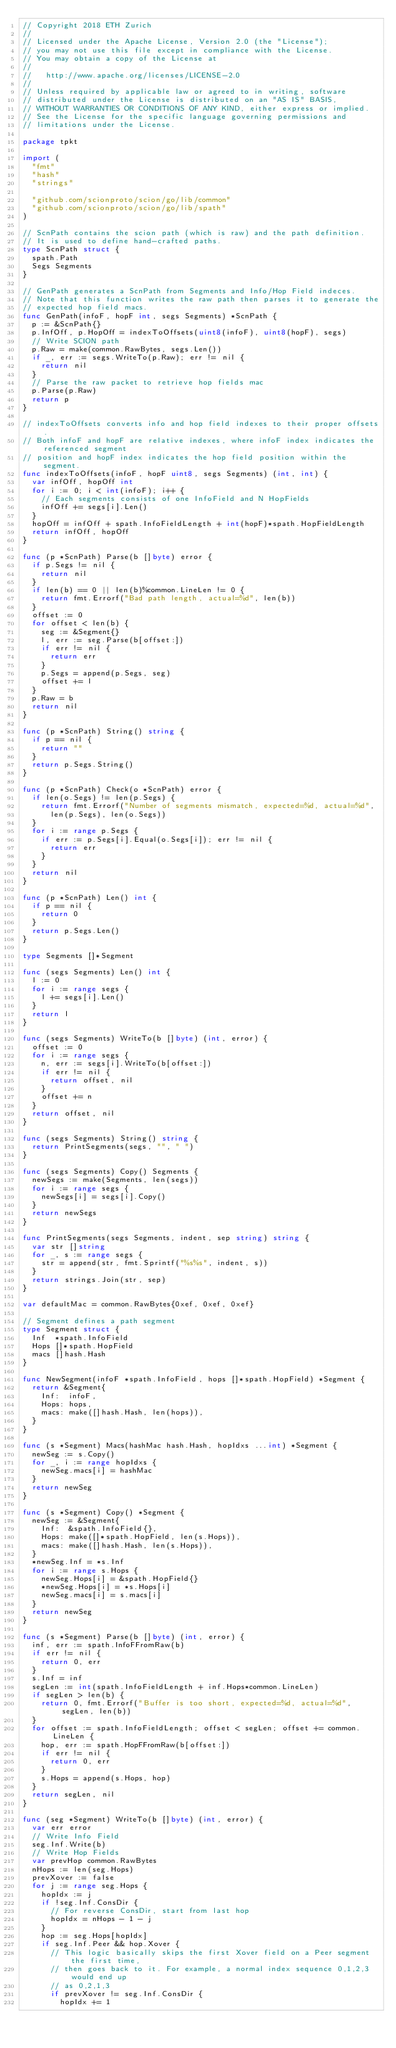<code> <loc_0><loc_0><loc_500><loc_500><_Go_>// Copyright 2018 ETH Zurich
//
// Licensed under the Apache License, Version 2.0 (the "License");
// you may not use this file except in compliance with the License.
// You may obtain a copy of the License at
//
//   http://www.apache.org/licenses/LICENSE-2.0
//
// Unless required by applicable law or agreed to in writing, software
// distributed under the License is distributed on an "AS IS" BASIS,
// WITHOUT WARRANTIES OR CONDITIONS OF ANY KIND, either express or implied.
// See the License for the specific language governing permissions and
// limitations under the License.

package tpkt

import (
	"fmt"
	"hash"
	"strings"

	"github.com/scionproto/scion/go/lib/common"
	"github.com/scionproto/scion/go/lib/spath"
)

// ScnPath contains the scion path (which is raw) and the path definition.
// It is used to define hand-crafted paths.
type ScnPath struct {
	spath.Path
	Segs Segments
}

// GenPath generates a ScnPath from Segments and Info/Hop Field indeces.
// Note that this function writes the raw path then parses it to generate the
// expected hop field macs.
func GenPath(infoF, hopF int, segs Segments) *ScnPath {
	p := &ScnPath{}
	p.InfOff, p.HopOff = indexToOffsets(uint8(infoF), uint8(hopF), segs)
	// Write SCION path
	p.Raw = make(common.RawBytes, segs.Len())
	if _, err := segs.WriteTo(p.Raw); err != nil {
		return nil
	}
	// Parse the raw packet to retrieve hop fields mac
	p.Parse(p.Raw)
	return p
}

// indexToOffsets converts info and hop field indexes to their proper offsets.
// Both infoF and hopF are relative indexes, where infoF index indicates the referenced segment
// position and hopF index indicates the hop field position within the segment.
func indexToOffsets(infoF, hopF uint8, segs Segments) (int, int) {
	var infOff, hopOff int
	for i := 0; i < int(infoF); i++ {
		// Each segments consists of one InfoField and N HopFields
		infOff += segs[i].Len()
	}
	hopOff = infOff + spath.InfoFieldLength + int(hopF)*spath.HopFieldLength
	return infOff, hopOff
}

func (p *ScnPath) Parse(b []byte) error {
	if p.Segs != nil {
		return nil
	}
	if len(b) == 0 || len(b)%common.LineLen != 0 {
		return fmt.Errorf("Bad path length, actual=%d", len(b))
	}
	offset := 0
	for offset < len(b) {
		seg := &Segment{}
		l, err := seg.Parse(b[offset:])
		if err != nil {
			return err
		}
		p.Segs = append(p.Segs, seg)
		offset += l
	}
	p.Raw = b
	return nil
}

func (p *ScnPath) String() string {
	if p == nil {
		return ""
	}
	return p.Segs.String()
}

func (p *ScnPath) Check(o *ScnPath) error {
	if len(o.Segs) != len(p.Segs) {
		return fmt.Errorf("Number of segments mismatch, expected=%d, actual=%d",
			len(p.Segs), len(o.Segs))
	}
	for i := range p.Segs {
		if err := p.Segs[i].Equal(o.Segs[i]); err != nil {
			return err
		}
	}
	return nil
}

func (p *ScnPath) Len() int {
	if p == nil {
		return 0
	}
	return p.Segs.Len()
}

type Segments []*Segment

func (segs Segments) Len() int {
	l := 0
	for i := range segs {
		l += segs[i].Len()
	}
	return l
}

func (segs Segments) WriteTo(b []byte) (int, error) {
	offset := 0
	for i := range segs {
		n, err := segs[i].WriteTo(b[offset:])
		if err != nil {
			return offset, nil
		}
		offset += n
	}
	return offset, nil
}

func (segs Segments) String() string {
	return PrintSegments(segs, "", " ")
}

func (segs Segments) Copy() Segments {
	newSegs := make(Segments, len(segs))
	for i := range segs {
		newSegs[i] = segs[i].Copy()
	}
	return newSegs
}

func PrintSegments(segs Segments, indent, sep string) string {
	var str []string
	for _, s := range segs {
		str = append(str, fmt.Sprintf("%s%s", indent, s))
	}
	return strings.Join(str, sep)
}

var defaultMac = common.RawBytes{0xef, 0xef, 0xef}

// Segment defines a path segment
type Segment struct {
	Inf  *spath.InfoField
	Hops []*spath.HopField
	macs []hash.Hash
}

func NewSegment(infoF *spath.InfoField, hops []*spath.HopField) *Segment {
	return &Segment{
		Inf:  infoF,
		Hops: hops,
		macs: make([]hash.Hash, len(hops)),
	}
}

func (s *Segment) Macs(hashMac hash.Hash, hopIdxs ...int) *Segment {
	newSeg := s.Copy()
	for _, i := range hopIdxs {
		newSeg.macs[i] = hashMac
	}
	return newSeg
}

func (s *Segment) Copy() *Segment {
	newSeg := &Segment{
		Inf:  &spath.InfoField{},
		Hops: make([]*spath.HopField, len(s.Hops)),
		macs: make([]hash.Hash, len(s.Hops)),
	}
	*newSeg.Inf = *s.Inf
	for i := range s.Hops {
		newSeg.Hops[i] = &spath.HopField{}
		*newSeg.Hops[i] = *s.Hops[i]
		newSeg.macs[i] = s.macs[i]
	}
	return newSeg
}

func (s *Segment) Parse(b []byte) (int, error) {
	inf, err := spath.InfoFFromRaw(b)
	if err != nil {
		return 0, err
	}
	s.Inf = inf
	segLen := int(spath.InfoFieldLength + inf.Hops*common.LineLen)
	if segLen > len(b) {
		return 0, fmt.Errorf("Buffer is too short, expected=%d, actual=%d", segLen, len(b))
	}
	for offset := spath.InfoFieldLength; offset < segLen; offset += common.LineLen {
		hop, err := spath.HopFFromRaw(b[offset:])
		if err != nil {
			return 0, err
		}
		s.Hops = append(s.Hops, hop)
	}
	return segLen, nil
}

func (seg *Segment) WriteTo(b []byte) (int, error) {
	var err error
	// Write Info Field
	seg.Inf.Write(b)
	// Write Hop Fields
	var prevHop common.RawBytes
	nHops := len(seg.Hops)
	prevXover := false
	for j := range seg.Hops {
		hopIdx := j
		if !seg.Inf.ConsDir {
			// For reverse ConsDir, start from last hop
			hopIdx = nHops - 1 - j
		}
		hop := seg.Hops[hopIdx]
		if seg.Inf.Peer && hop.Xover {
			// This logic basically skips the first Xover field on a Peer segment the first time,
			// then goes back to it. For example, a normal index sequence 0,1,2,3 would end up
			// as 0,2,1,3
			if prevXover != seg.Inf.ConsDir {
				hopIdx += 1</code> 